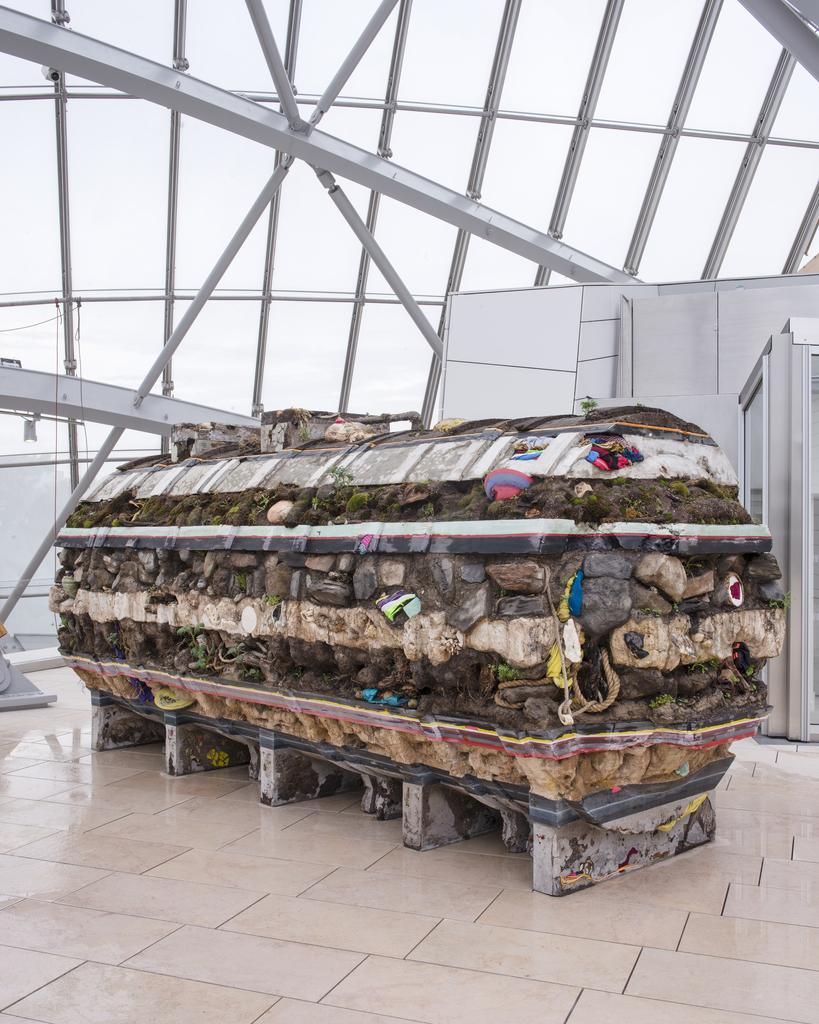What is the main subject in the foreground of the image? There is a horizontal cylindrical shaped stone structure in the foreground of the image. Can you describe the position of the stone structure? The stone structure is on the floor. What can be seen in the background of the image? There is a glass ceiling and a white wall in the background of the image. Who is sitting on the throne in the image? There is no throne present in the image; it features a horizontal cylindrical shaped stone structure on the floor. What type of farm can be seen in the background of the image? There is no farm present in the image; it features a glass ceiling and a white wall in the background. 